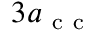Convert formula to latex. <formula><loc_0><loc_0><loc_500><loc_500>3 a _ { c c }</formula> 